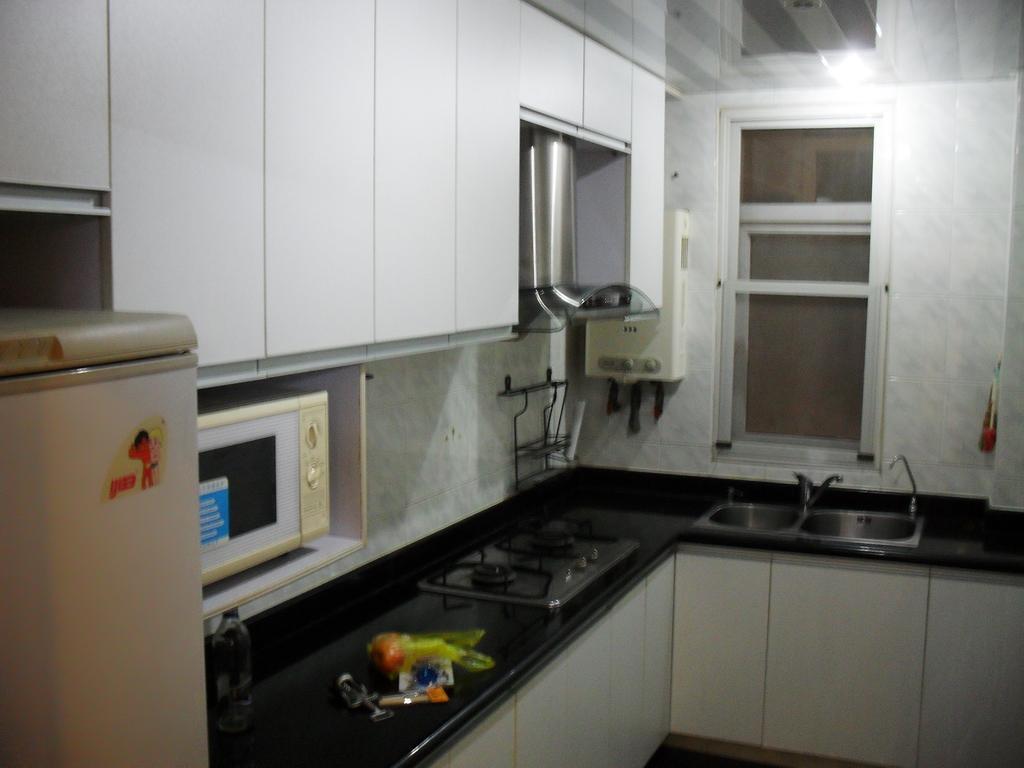In one or two sentences, can you explain what this image depicts? In this image there is a kitchen, in that kitchen there is a gas stove, sink, micro oven, fridge, at the top there is a cupboard, in the background there is a wall to that wall there is a window. 